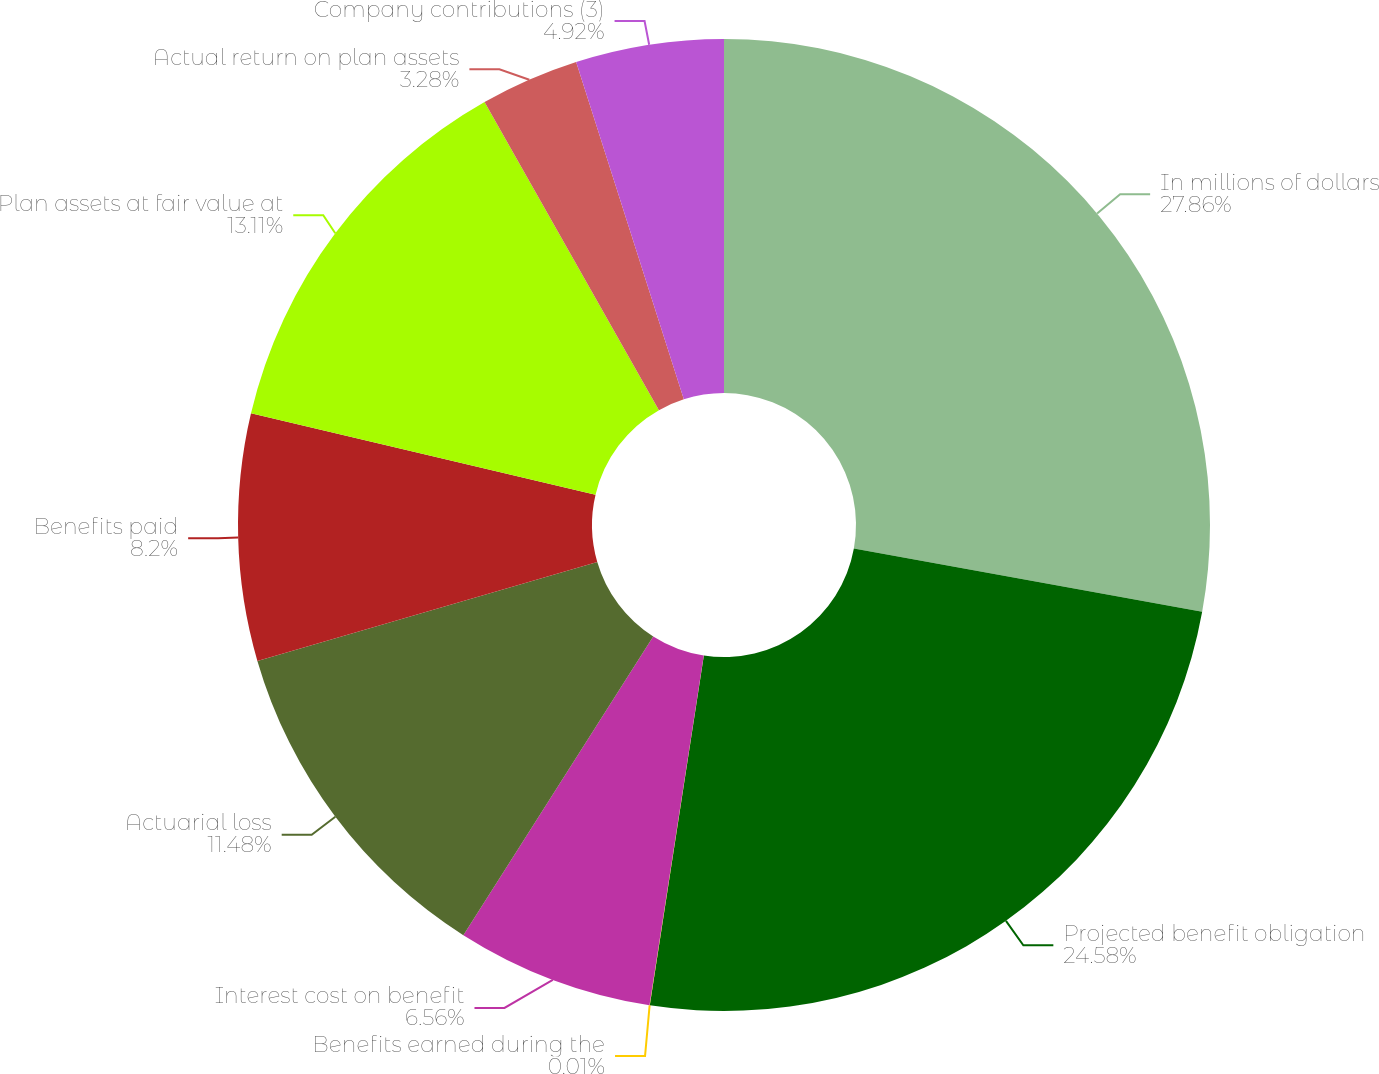Convert chart to OTSL. <chart><loc_0><loc_0><loc_500><loc_500><pie_chart><fcel>In millions of dollars<fcel>Projected benefit obligation<fcel>Benefits earned during the<fcel>Interest cost on benefit<fcel>Actuarial loss<fcel>Benefits paid<fcel>Plan assets at fair value at<fcel>Actual return on plan assets<fcel>Company contributions (3)<nl><fcel>27.86%<fcel>24.58%<fcel>0.01%<fcel>6.56%<fcel>11.48%<fcel>8.2%<fcel>13.11%<fcel>3.28%<fcel>4.92%<nl></chart> 